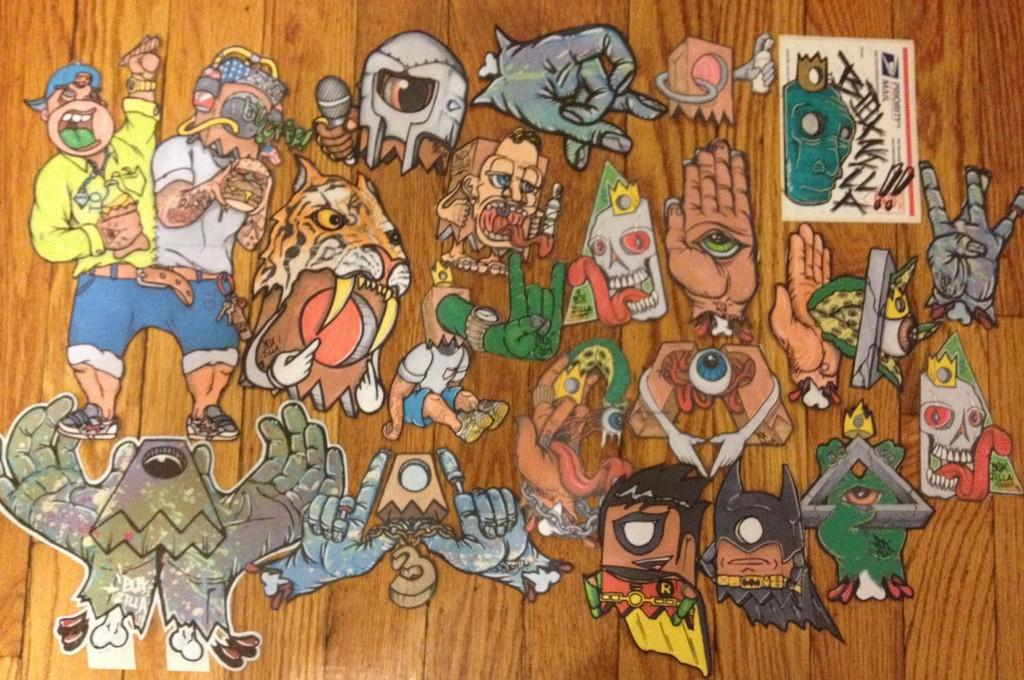What is on the wooden plank in the image? There are stickers on a wooden plank in the image. What can be observed about the stickers? The stickers are of different kinds. What type of alarm is attached to the wooden plank in the image? There is no alarm present on the wooden plank in the image; it only has stickers. 